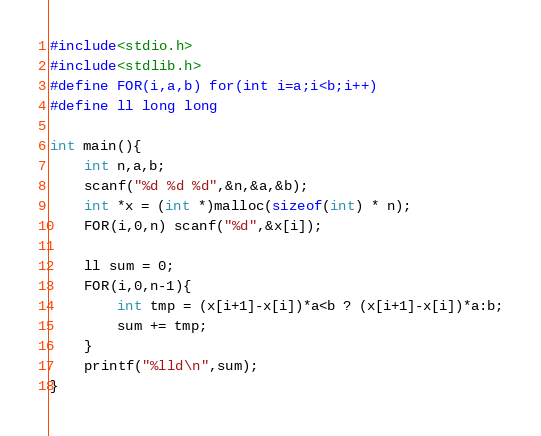Convert code to text. <code><loc_0><loc_0><loc_500><loc_500><_C_>#include<stdio.h>
#include<stdlib.h>
#define FOR(i,a,b) for(int i=a;i<b;i++)
#define ll long long

int main(){
	int n,a,b;
	scanf("%d %d %d",&n,&a,&b);
	int *x = (int *)malloc(sizeof(int) * n);
	FOR(i,0,n) scanf("%d",&x[i]);

	ll sum = 0;
	FOR(i,0,n-1){
		int tmp = (x[i+1]-x[i])*a<b ? (x[i+1]-x[i])*a:b;
		sum += tmp;
	}
	printf("%lld\n",sum);
}</code> 